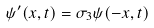<formula> <loc_0><loc_0><loc_500><loc_500>\psi ^ { \prime } ( x , t ) = \sigma _ { 3 } \psi ( - x , t )</formula> 